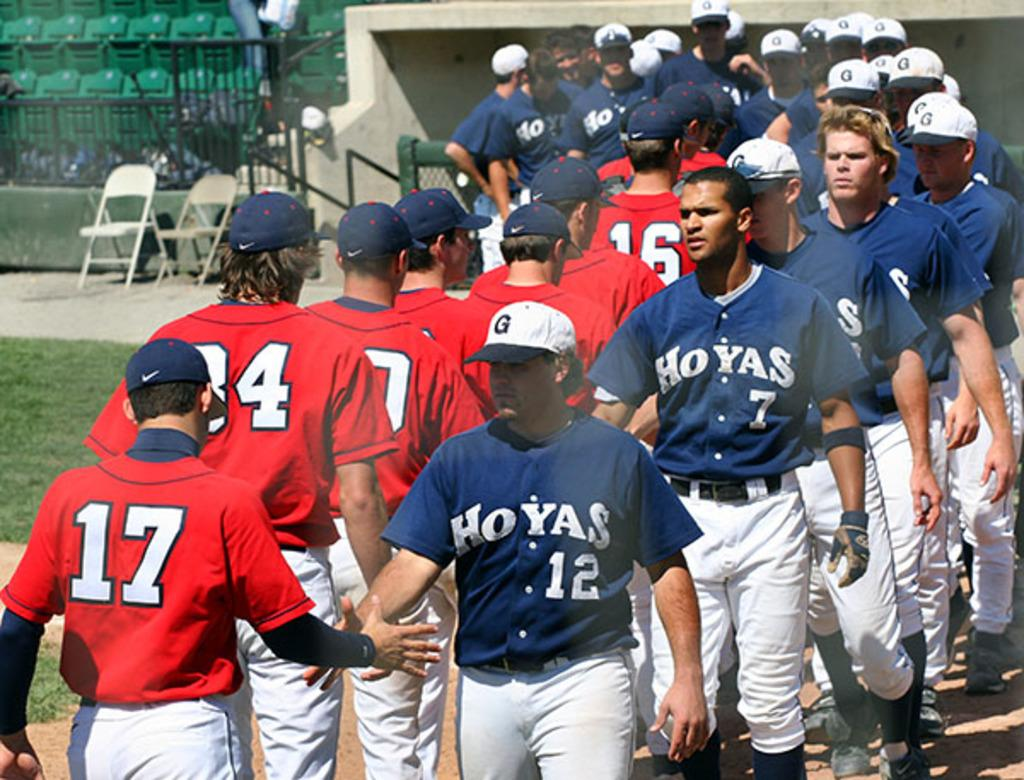<image>
Create a compact narrative representing the image presented. A Hoyas baseball team walking in a line and shaking hands with the members of another team. 